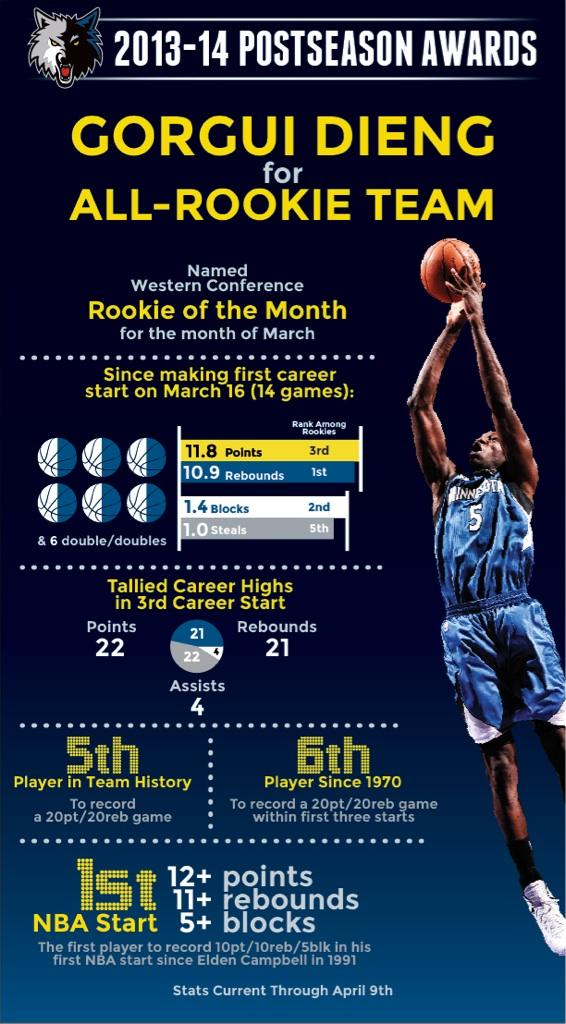Indicate a few pertinent items in this graphic. Elden Campbell was the first NBA player to record 10 points, 10 rebounds, and 5 blocks in his first start. Four players had previously recorded a 20-point, 20-rebound game before the current player achieved the feat. To date, only five players have recorded a 20-point, 20-rebound performance in their first three career starts, a rare feat that showcases exceptional skill and dominance on the basketball court. He holds the first rank among rookies in rebounds," declares. The number on the jersey is 5. 